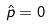<formula> <loc_0><loc_0><loc_500><loc_500>\hat { p } = 0</formula> 